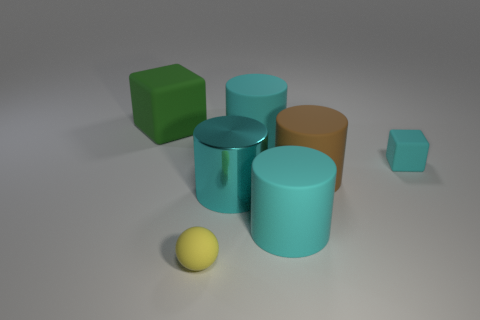What number of other objects are there of the same color as the large metal cylinder?
Give a very brief answer. 3. There is a tiny block; does it have the same color as the large matte thing in front of the brown rubber cylinder?
Offer a terse response. Yes. What number of cyan objects are either big objects or matte things?
Ensure brevity in your answer.  4. Are there the same number of cyan matte cylinders that are behind the large matte block and tiny brown metal balls?
Keep it short and to the point. Yes. The other metallic thing that is the same shape as the large brown thing is what color?
Offer a terse response. Cyan. What number of tiny cyan rubber things have the same shape as the yellow object?
Give a very brief answer. 0. There is a small cube that is the same color as the big metal cylinder; what material is it?
Keep it short and to the point. Rubber. What number of large gray cylinders are there?
Keep it short and to the point. 0. Are there any cyan cylinders made of the same material as the tiny cyan thing?
Your response must be concise. Yes. There is a rubber block that is the same color as the metal cylinder; what size is it?
Your response must be concise. Small. 